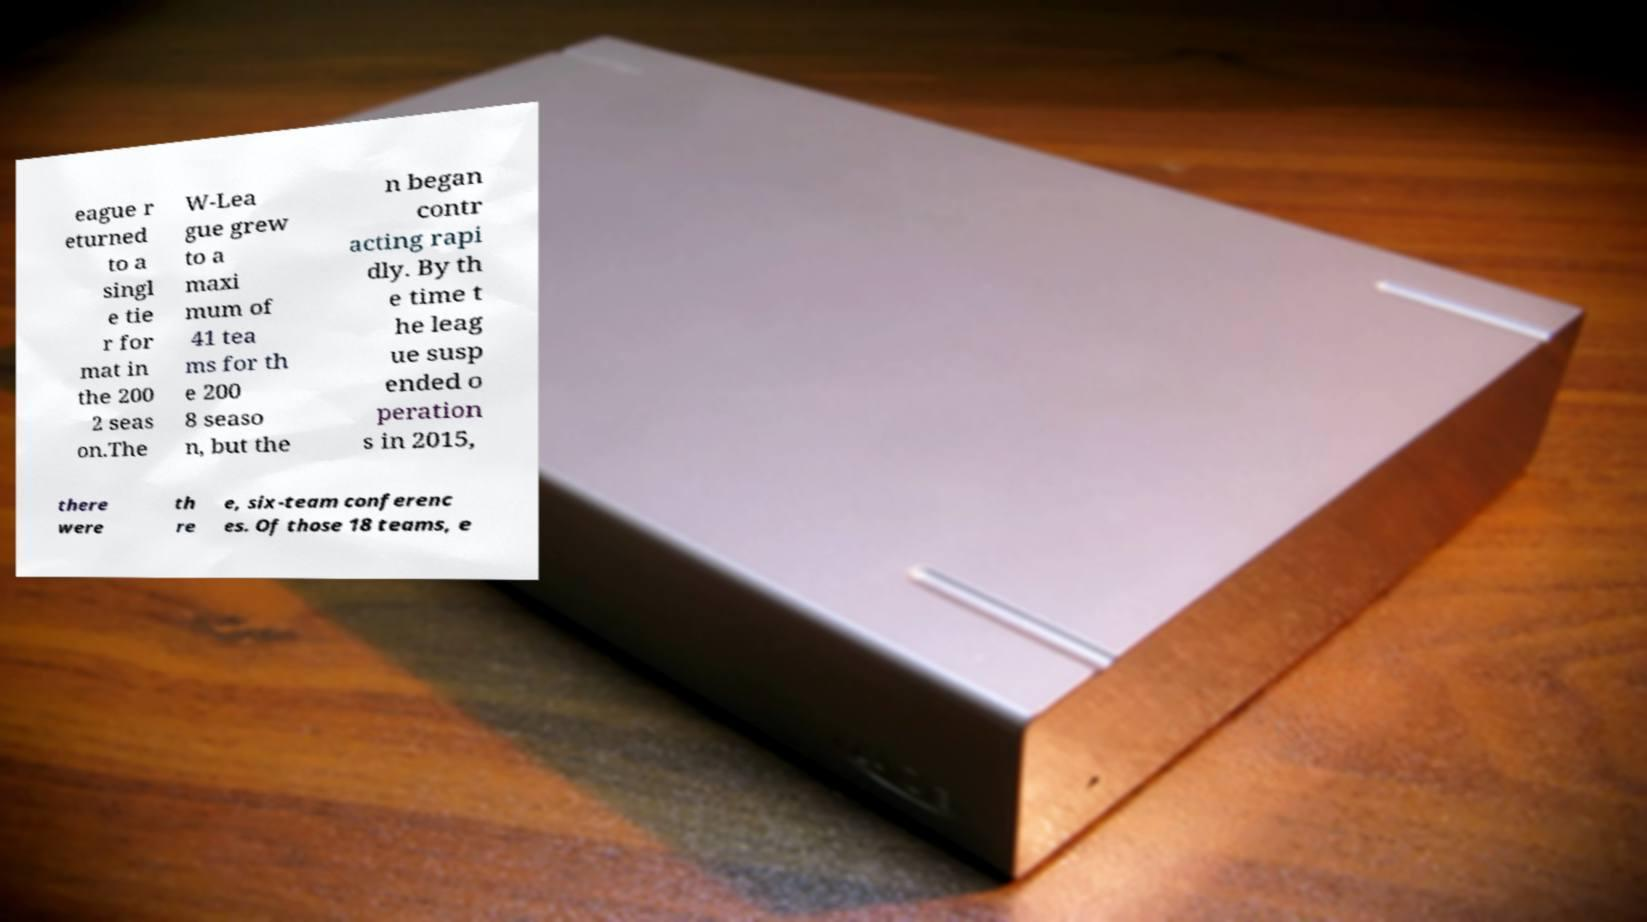Can you accurately transcribe the text from the provided image for me? eague r eturned to a singl e tie r for mat in the 200 2 seas on.The W-Lea gue grew to a maxi mum of 41 tea ms for th e 200 8 seaso n, but the n began contr acting rapi dly. By th e time t he leag ue susp ended o peration s in 2015, there were th re e, six-team conferenc es. Of those 18 teams, e 